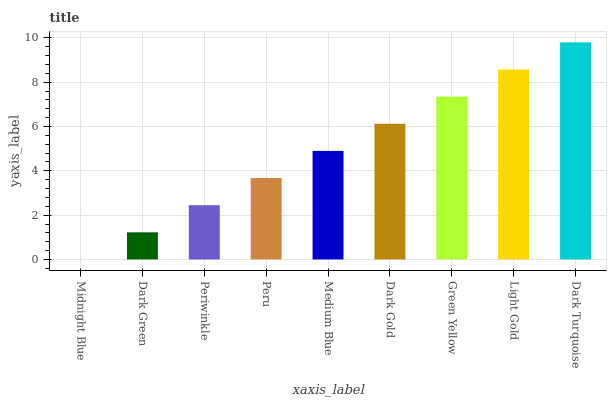Is Midnight Blue the minimum?
Answer yes or no. Yes. Is Dark Turquoise the maximum?
Answer yes or no. Yes. Is Dark Green the minimum?
Answer yes or no. No. Is Dark Green the maximum?
Answer yes or no. No. Is Dark Green greater than Midnight Blue?
Answer yes or no. Yes. Is Midnight Blue less than Dark Green?
Answer yes or no. Yes. Is Midnight Blue greater than Dark Green?
Answer yes or no. No. Is Dark Green less than Midnight Blue?
Answer yes or no. No. Is Medium Blue the high median?
Answer yes or no. Yes. Is Medium Blue the low median?
Answer yes or no. Yes. Is Dark Gold the high median?
Answer yes or no. No. Is Dark Turquoise the low median?
Answer yes or no. No. 